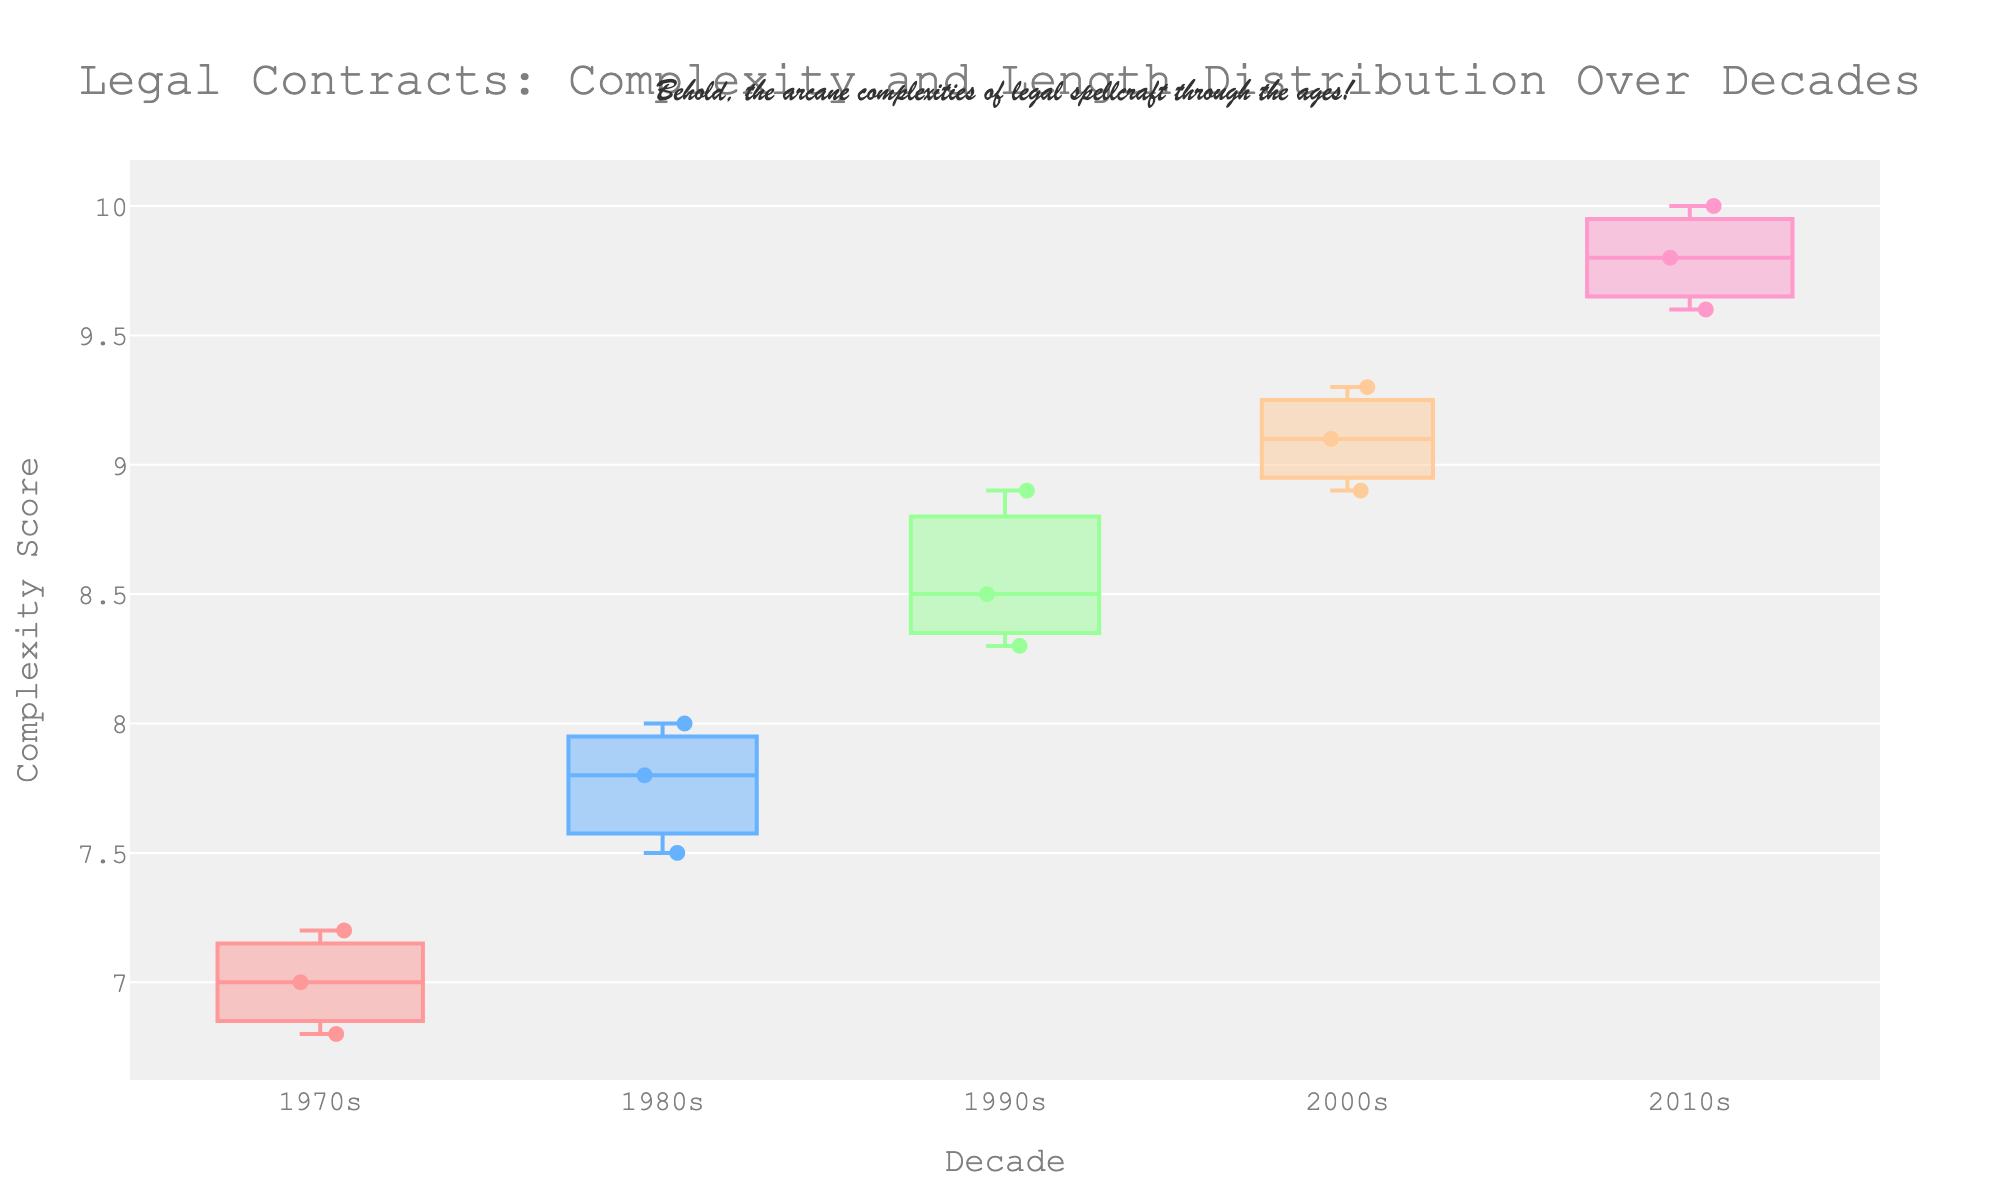What is the title of the figure? The title can be found at the top of the figure, which provides an overview of what the plot shows.
Answer: "Legal Contracts: Complexity and Length Distribution Over Decades" How many decades are shown on the x-axis? By looking at the x-axis, we can see the distinct categories representing decades.
Answer: 5 Which decade has the highest median complexity score? By examining the position of the central line within each box plot, which represents the median, we can identify the highest median.
Answer: 2010s What is the complexity score range in the 2000s? By looking at the top and bottom of the "box" part of the box plot for the 2000s, we observe the interquartile range (IQR), which spans the 1st to the 3rd quartile.
Answer: 8.9 to 9.3 Does the plot show a general trend of increasing complexity over time? By observing the median lines of the box plots from left (older decades) to right (newer decades), we can assess if there is a rising pattern.
Answer: Yes Which decade has the widest box, indicating the largest interquartile range (IQR)? The width of the box, not the entire plot width, shows the spread of the middle 50% of the data; the box with the widest span vertically indicates the largest IQR.
Answer: 2010s How does the median complexity score in the 1990s compare to the median in the 1970s? By visually comparing the central lines in the box plots of the 1990s and 1970s, we compare their medians.
Answer: Higher What is the significance of the box width for each decade in this plot? The width of the box in a variable width box plot indicates the relative frequency of the data points in each decade, showing the sample size proportion.
Answer: Indicates sample size Do all the decades have the same maximum complexity score? By comparing the topmost points (outliers) in box plots across all decades, we can determine if any complexity scores go beyond the typical range uniformly.
Answer: No 